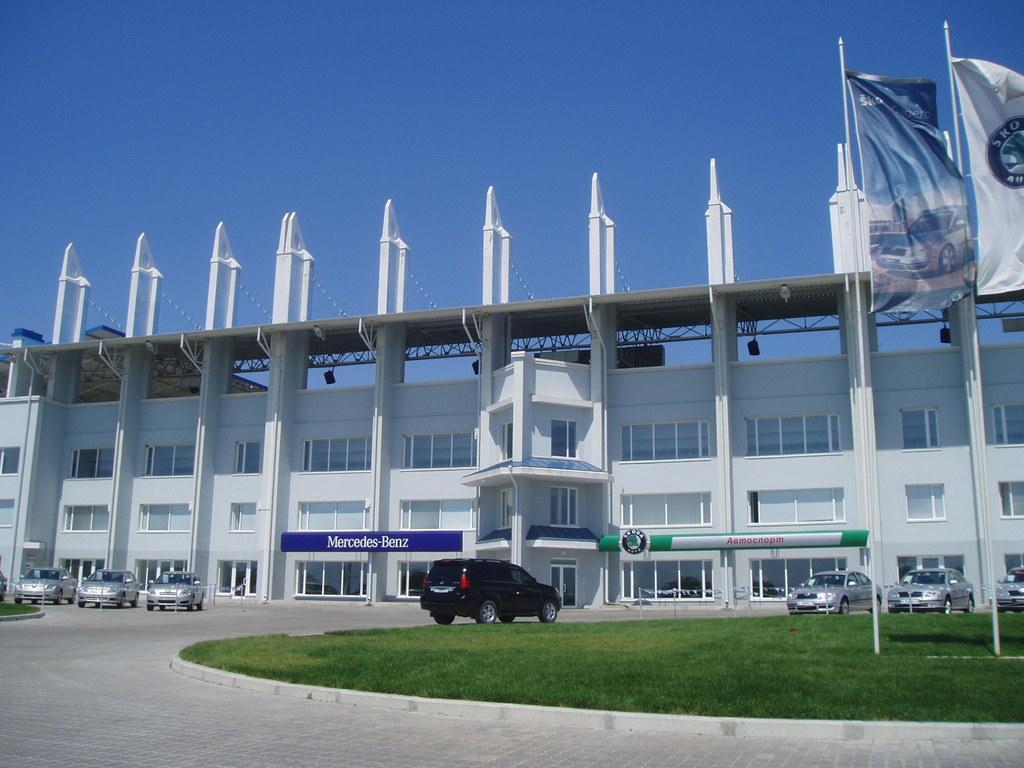Describe this image in one or two sentences. In this image there is a building. in front of it there are many cars. Here there is a grassland. There are flags. The sky is clear. 